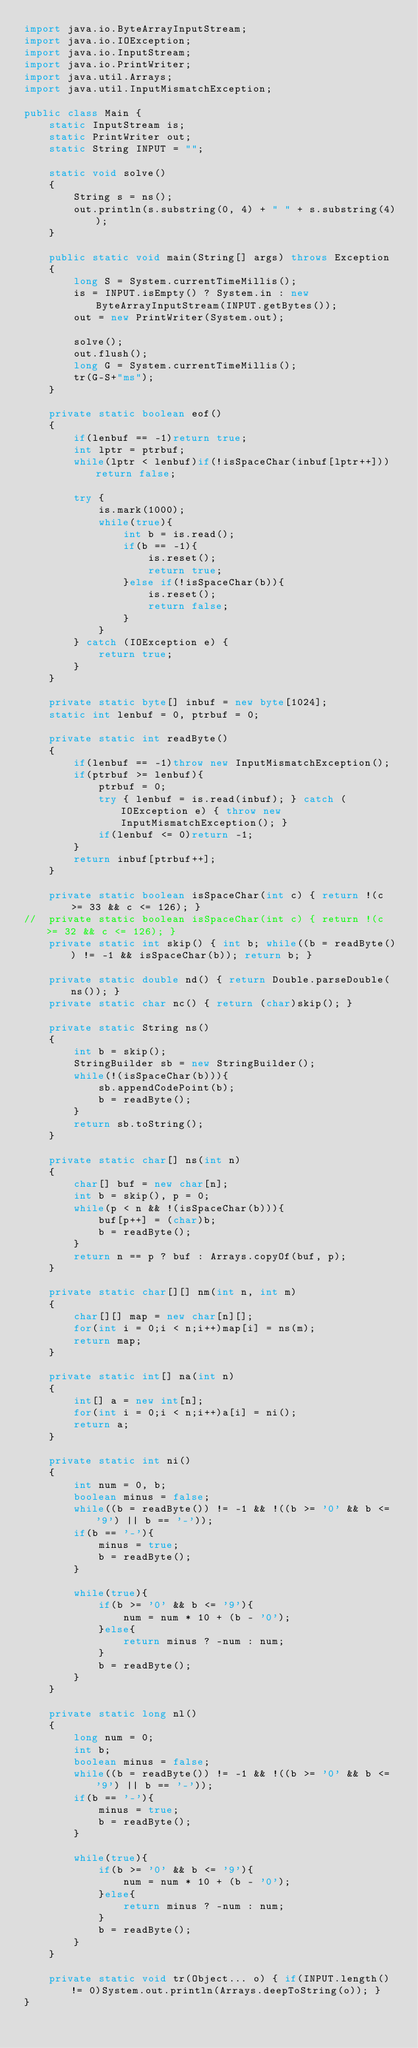Convert code to text. <code><loc_0><loc_0><loc_500><loc_500><_Java_>import java.io.ByteArrayInputStream;
import java.io.IOException;
import java.io.InputStream;
import java.io.PrintWriter;
import java.util.Arrays;
import java.util.InputMismatchException;

public class Main {
	static InputStream is;
	static PrintWriter out;
	static String INPUT = "";
	
	static void solve()
	{
		String s = ns();
		out.println(s.substring(0, 4) + " " + s.substring(4));
	}
	
	public static void main(String[] args) throws Exception
	{
		long S = System.currentTimeMillis();
		is = INPUT.isEmpty() ? System.in : new ByteArrayInputStream(INPUT.getBytes());
		out = new PrintWriter(System.out);
		
		solve();
		out.flush();
		long G = System.currentTimeMillis();
		tr(G-S+"ms");
	}
	
	private static boolean eof()
	{
		if(lenbuf == -1)return true;
		int lptr = ptrbuf;
		while(lptr < lenbuf)if(!isSpaceChar(inbuf[lptr++]))return false;
		
		try {
			is.mark(1000);
			while(true){
				int b = is.read();
				if(b == -1){
					is.reset();
					return true;
				}else if(!isSpaceChar(b)){
					is.reset();
					return false;
				}
			}
		} catch (IOException e) {
			return true;
		}
	}
	
	private static byte[] inbuf = new byte[1024];
	static int lenbuf = 0, ptrbuf = 0;
	
	private static int readByte()
	{
		if(lenbuf == -1)throw new InputMismatchException();
		if(ptrbuf >= lenbuf){
			ptrbuf = 0;
			try { lenbuf = is.read(inbuf); } catch (IOException e) { throw new InputMismatchException(); }
			if(lenbuf <= 0)return -1;
		}
		return inbuf[ptrbuf++];
	}
	
	private static boolean isSpaceChar(int c) { return !(c >= 33 && c <= 126); }
//	private static boolean isSpaceChar(int c) { return !(c >= 32 && c <= 126); }
	private static int skip() { int b; while((b = readByte()) != -1 && isSpaceChar(b)); return b; }
	
	private static double nd() { return Double.parseDouble(ns()); }
	private static char nc() { return (char)skip(); }
	
	private static String ns()
	{
		int b = skip();
		StringBuilder sb = new StringBuilder();
		while(!(isSpaceChar(b))){
			sb.appendCodePoint(b);
			b = readByte();
		}
		return sb.toString();
	}
	
	private static char[] ns(int n)
	{
		char[] buf = new char[n];
		int b = skip(), p = 0;
		while(p < n && !(isSpaceChar(b))){
			buf[p++] = (char)b;
			b = readByte();
		}
		return n == p ? buf : Arrays.copyOf(buf, p);
	}
	
	private static char[][] nm(int n, int m)
	{
		char[][] map = new char[n][];
		for(int i = 0;i < n;i++)map[i] = ns(m);
		return map;
	}
	
	private static int[] na(int n)
	{
		int[] a = new int[n];
		for(int i = 0;i < n;i++)a[i] = ni();
		return a;
	}
	
	private static int ni()
	{
		int num = 0, b;
		boolean minus = false;
		while((b = readByte()) != -1 && !((b >= '0' && b <= '9') || b == '-'));
		if(b == '-'){
			minus = true;
			b = readByte();
		}
		
		while(true){
			if(b >= '0' && b <= '9'){
				num = num * 10 + (b - '0');
			}else{
				return minus ? -num : num;
			}
			b = readByte();
		}
	}
	
	private static long nl()
	{
		long num = 0;
		int b;
		boolean minus = false;
		while((b = readByte()) != -1 && !((b >= '0' && b <= '9') || b == '-'));
		if(b == '-'){
			minus = true;
			b = readByte();
		}
		
		while(true){
			if(b >= '0' && b <= '9'){
				num = num * 10 + (b - '0');
			}else{
				return minus ? -num : num;
			}
			b = readByte();
		}
	}
	
	private static void tr(Object... o) { if(INPUT.length() != 0)System.out.println(Arrays.deepToString(o)); }
}
</code> 